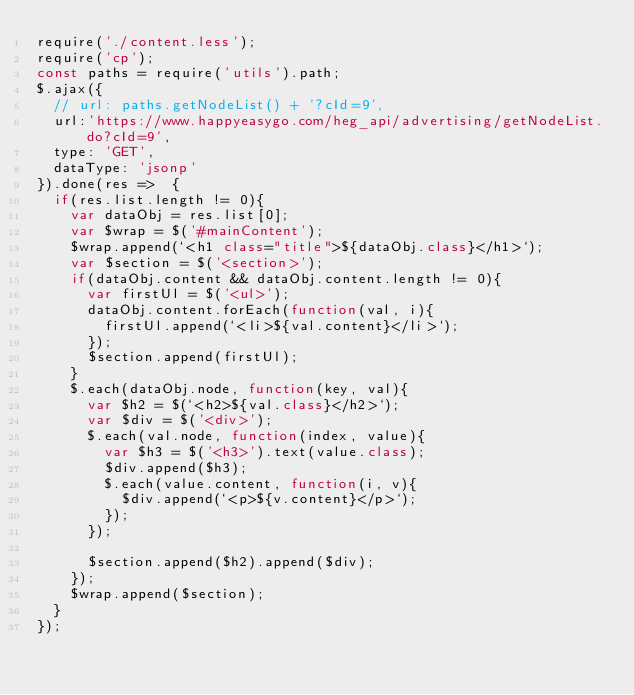<code> <loc_0><loc_0><loc_500><loc_500><_JavaScript_>require('./content.less');
require('cp');
const paths = require('utils').path;
$.ajax({
  // url: paths.getNodeList() + '?cId=9',
  url:'https://www.happyeasygo.com/heg_api/advertising/getNodeList.do?cId=9',
  type: 'GET',
  dataType: 'jsonp'
}).done(res =>  {
  if(res.list.length != 0){
    var dataObj = res.list[0];
    var $wrap = $('#mainContent');
    $wrap.append(`<h1 class="title">${dataObj.class}</h1>`);
    var $section = $('<section>');
    if(dataObj.content && dataObj.content.length != 0){
      var firstUl = $('<ul>');
      dataObj.content.forEach(function(val, i){
        firstUl.append(`<li>${val.content}</li>`);
      });
      $section.append(firstUl);
    }
    $.each(dataObj.node, function(key, val){
      var $h2 = $(`<h2>${val.class}</h2>`);
      var $div = $('<div>');
      $.each(val.node, function(index, value){
        var $h3 = $('<h3>').text(value.class);
        $div.append($h3);
        $.each(value.content, function(i, v){
          $div.append(`<p>${v.content}</p>`);
        });
      });

      $section.append($h2).append($div);
    });
    $wrap.append($section);
  }
});</code> 